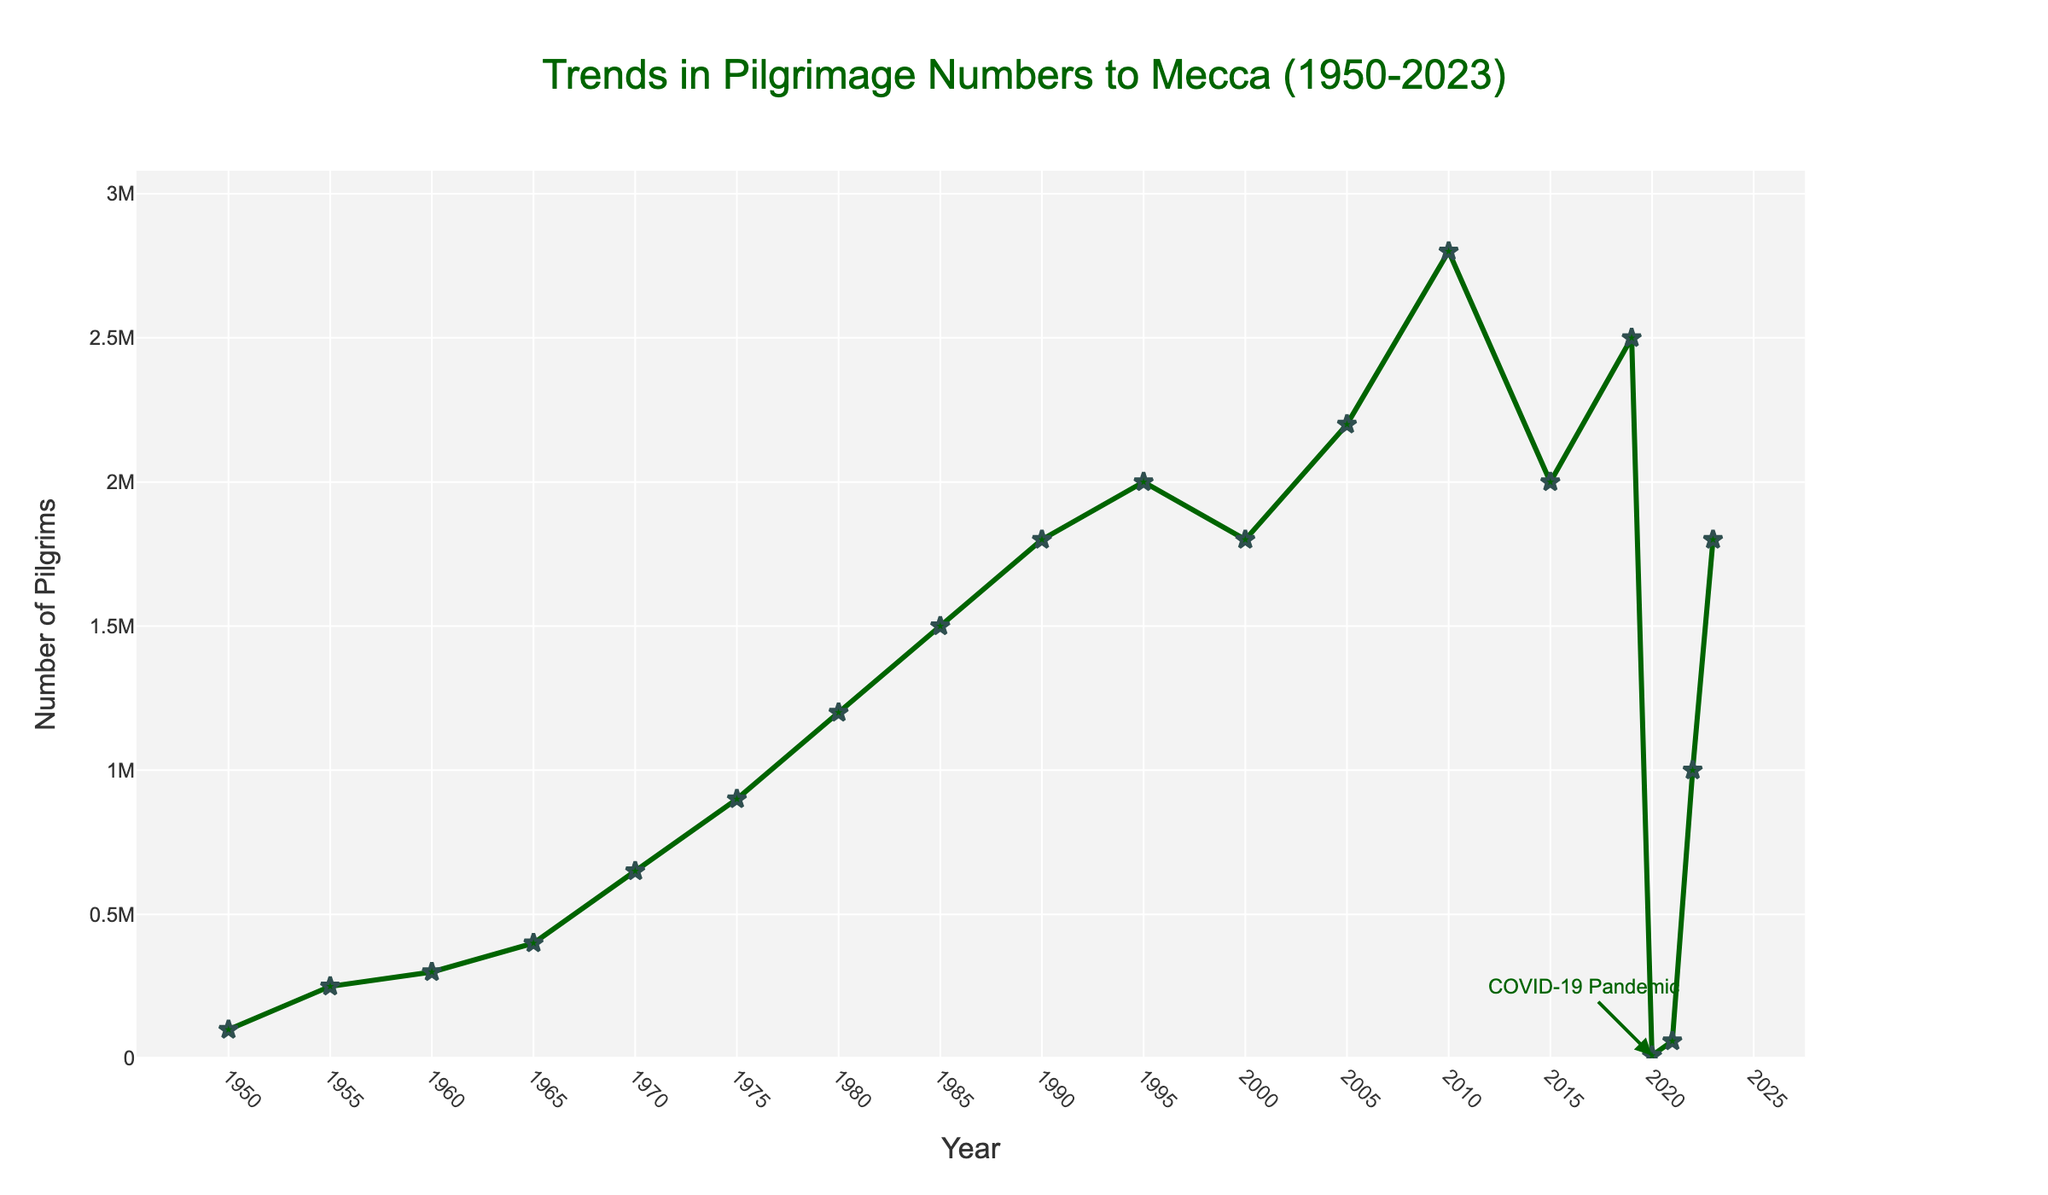what is the trend in pilgrimage numbers between 1950 to 2023? The trend shows a general increase in pilgrimage numbers from 1950 to 2023, with notable increases especially in the late 20th century. However, there was a significant drop in 2020 and 2021, likely due to the COVID-19 pandemic. This trend is observed by following the line plot, which generally ascends over time, with major dips in 2020 and 2021.
Answer: General increase with a significant drop in 2020 and 2021 what was the number of pilgrims in the year 2000 and how does it compare to 1995? In the year 2000, the number of pilgrims was 1,800,000. In 1995, it was 2,000,000. Comparing the two, the number decreased by 200,000 in 2000 compared to 1995. This is determined by checking the plot points for the respective years and observing the vertical distance between them.
Answer: Decreased by 200,000 in which year did the number of pilgrims surpass one million for the first time? The number of pilgrims surpassed one million for the first time in 1975. This is identified by locating the point on the plot where the number of pilgrims crosses the one million mark for the first time.
Answer: 1975 how did the number of pilgrims in 2010 compare to 2015? In 2010, the number of pilgrims was 2,800,000. In 2015, it was 2,000,000. Thus, there was a decrease of 800,000 pilgrims from 2010 to 2015. This is assessed by comparing the values on the Y-axis for these years on the plot.
Answer: Decreased by 800,000 what is the maximum number of pilgrims recorded and in which year did this occur? The maximum number of pilgrims recorded was 2,800,000 in the year 2010. This is seen by identifying the highest point on the plot.
Answer: 2,800,000 in 2010 how does the trend in the 1980s compare to the trend in the 1990s? In the 1980s, the number of pilgrims steadily increased from 1,200,000 in 1980 to 1,500,000 in 1985, and then to 1,800,000 in 1990. In contrast, in the 1990s, the numbers showed a steadier increase from 1,800,000 in 1990 to 2,000,000 in 1995, remaining constant until 2000. The trend in the 1980s shows a slightly steeper increase compared to the 1990s.
Answer: 1980s had a steeper increase how does the color and style of the line help in understanding the data? The green color and the use of markers along with lines make it easier to distinguish the plot and the data points. The green line stands out against the background, and the star markers highlight the data points, allowing for easy identification of the years and the number of pilgrims.
Answer: Enhances readability and distinctness which year experienced the greatest increase in the number of pilgrims from the previous year? The greatest increase in the number of pilgrims from the previous year occurred between 2010 and 2005, where the number increased from 2,200,000 in 2005 to 2,800,000 in 2010. This 600,000 increase is identified by checking the differences in the number of pilgrims year over year on the plot.
Answer: 2010 (600,000 increase from 2005) what impact did the COVID-19 pandemic have on pilgrimage numbers in 2020 and 2021? The COVID-19 pandemic caused a drastic reduction in pilgrimage numbers in 2020 and 2021, with numbers dropping to 10,000 in 2020 and slightly increasing to 60,000 in 2021. This is evident by the sharp decline in the plot for these two years and is further annotated in the graph.
Answer: Significant reduction to 10,000 in 2020 and 60,000 in 2021 what was the trend immediately before and after the COVID-19 pandemic period? Before the COVID-19 pandemic, the trend showed numbers at 2,500,000 in 2019. During the pandemic, numbers dropped dramatically to 10,000 in 2020 and 60,000 in 2021. After the pandemic, the numbers started to recover, increasing to 1,000,000 in 2022 and 1,800,000 in 2023. This can be observed by comparing the plot points for these years.
Answer: Steady high numbers before 2019, sharp drop in 2020/2021, recovery starting in 2022 